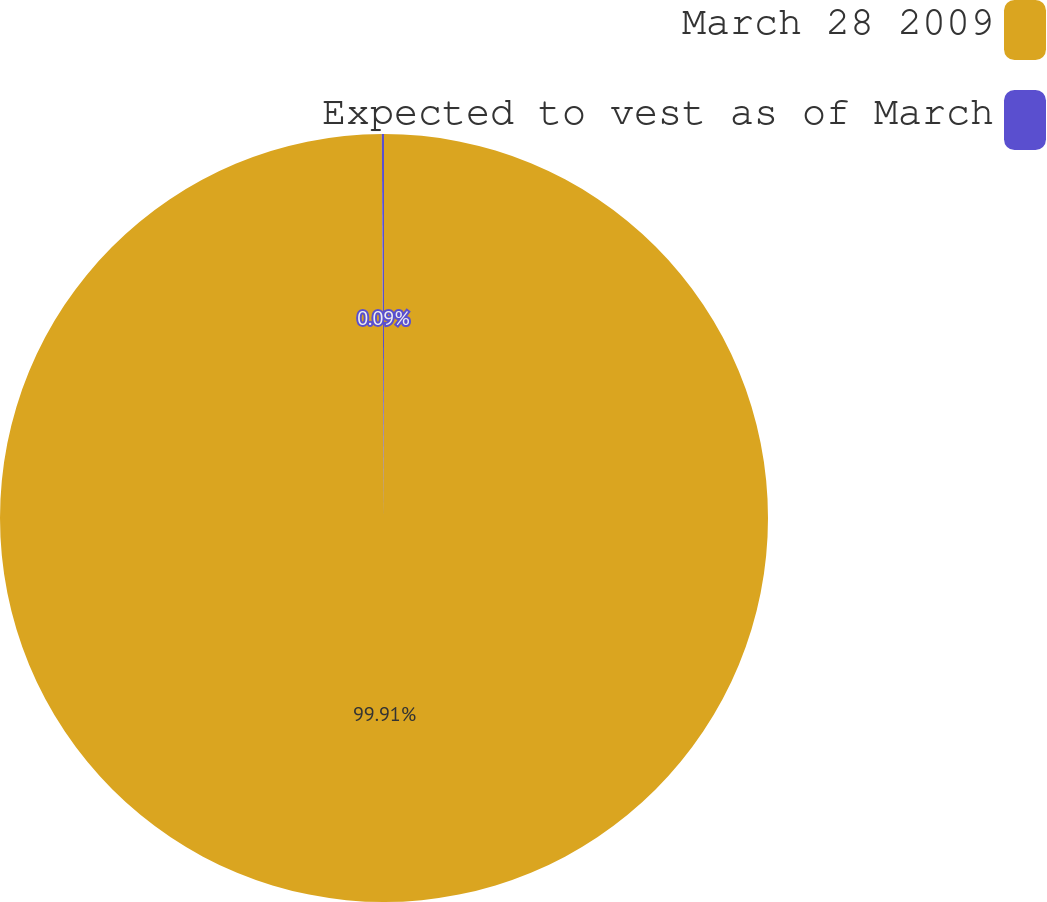Convert chart. <chart><loc_0><loc_0><loc_500><loc_500><pie_chart><fcel>March 28 2009<fcel>Expected to vest as of March<nl><fcel>99.91%<fcel>0.09%<nl></chart> 